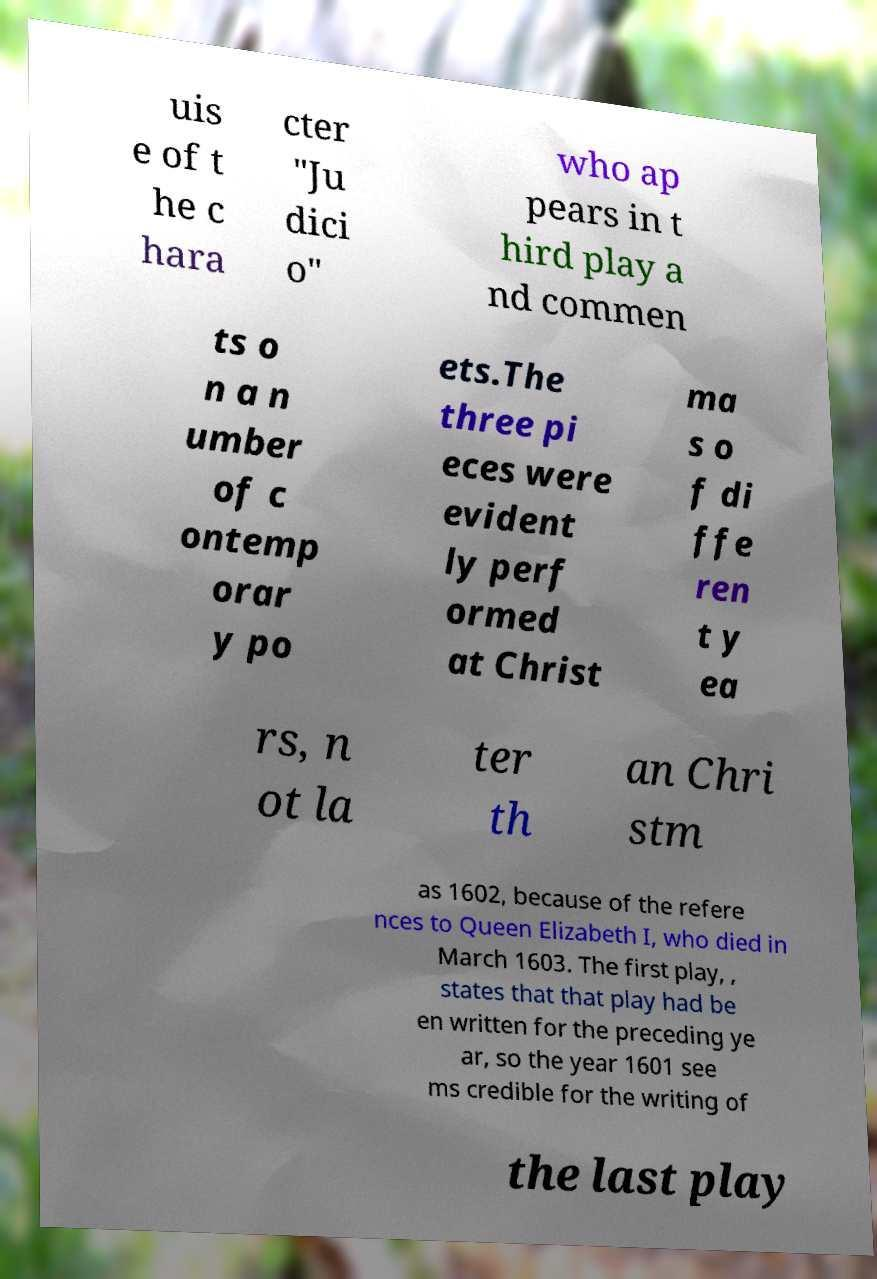Please identify and transcribe the text found in this image. uis e of t he c hara cter "Ju dici o" who ap pears in t hird play a nd commen ts o n a n umber of c ontemp orar y po ets.The three pi eces were evident ly perf ormed at Christ ma s o f di ffe ren t y ea rs, n ot la ter th an Chri stm as 1602, because of the refere nces to Queen Elizabeth I, who died in March 1603. The first play, , states that that play had be en written for the preceding ye ar, so the year 1601 see ms credible for the writing of the last play 